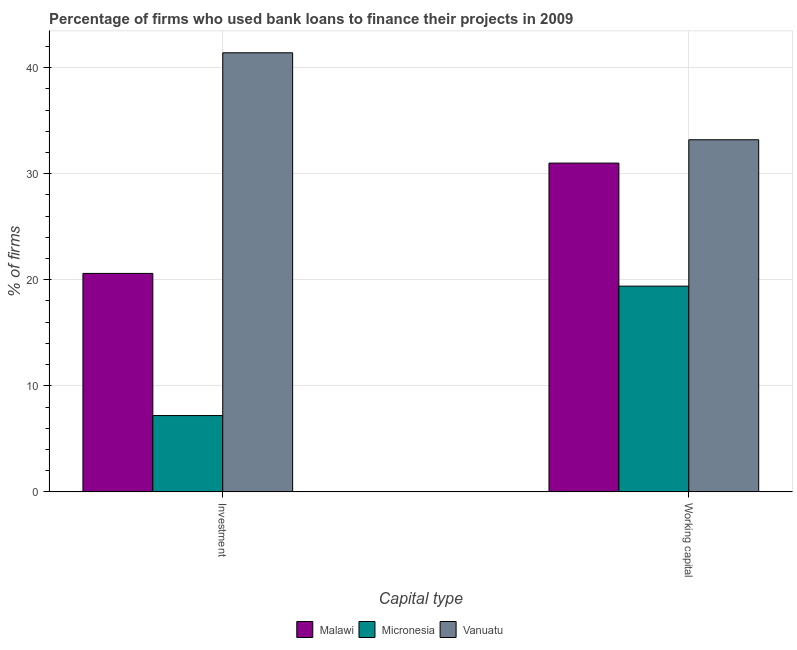How many different coloured bars are there?
Your answer should be very brief. 3. How many bars are there on the 1st tick from the left?
Ensure brevity in your answer.  3. What is the label of the 2nd group of bars from the left?
Provide a short and direct response. Working capital. What is the percentage of firms using banks to finance working capital in Vanuatu?
Make the answer very short. 33.2. Across all countries, what is the maximum percentage of firms using banks to finance working capital?
Your response must be concise. 33.2. Across all countries, what is the minimum percentage of firms using banks to finance investment?
Your response must be concise. 7.2. In which country was the percentage of firms using banks to finance investment maximum?
Offer a very short reply. Vanuatu. In which country was the percentage of firms using banks to finance working capital minimum?
Provide a short and direct response. Micronesia. What is the total percentage of firms using banks to finance working capital in the graph?
Provide a short and direct response. 83.6. What is the difference between the percentage of firms using banks to finance investment in Malawi and that in Vanuatu?
Your response must be concise. -20.8. What is the difference between the percentage of firms using banks to finance investment in Vanuatu and the percentage of firms using banks to finance working capital in Malawi?
Offer a very short reply. 10.4. What is the average percentage of firms using banks to finance working capital per country?
Provide a short and direct response. 27.87. What is the difference between the percentage of firms using banks to finance working capital and percentage of firms using banks to finance investment in Vanuatu?
Your answer should be very brief. -8.2. What is the ratio of the percentage of firms using banks to finance working capital in Micronesia to that in Malawi?
Make the answer very short. 0.63. In how many countries, is the percentage of firms using banks to finance investment greater than the average percentage of firms using banks to finance investment taken over all countries?
Ensure brevity in your answer.  1. What does the 3rd bar from the left in Working capital represents?
Offer a terse response. Vanuatu. What does the 1st bar from the right in Working capital represents?
Make the answer very short. Vanuatu. How many bars are there?
Your answer should be compact. 6. Are all the bars in the graph horizontal?
Your answer should be very brief. No. Are the values on the major ticks of Y-axis written in scientific E-notation?
Make the answer very short. No. How many legend labels are there?
Keep it short and to the point. 3. How are the legend labels stacked?
Give a very brief answer. Horizontal. What is the title of the graph?
Offer a terse response. Percentage of firms who used bank loans to finance their projects in 2009. Does "Croatia" appear as one of the legend labels in the graph?
Offer a very short reply. No. What is the label or title of the X-axis?
Your answer should be compact. Capital type. What is the label or title of the Y-axis?
Your answer should be compact. % of firms. What is the % of firms of Malawi in Investment?
Keep it short and to the point. 20.6. What is the % of firms in Vanuatu in Investment?
Make the answer very short. 41.4. What is the % of firms in Vanuatu in Working capital?
Keep it short and to the point. 33.2. Across all Capital type, what is the maximum % of firms of Vanuatu?
Provide a short and direct response. 41.4. Across all Capital type, what is the minimum % of firms of Malawi?
Make the answer very short. 20.6. Across all Capital type, what is the minimum % of firms in Vanuatu?
Your response must be concise. 33.2. What is the total % of firms of Malawi in the graph?
Keep it short and to the point. 51.6. What is the total % of firms in Micronesia in the graph?
Provide a short and direct response. 26.6. What is the total % of firms in Vanuatu in the graph?
Keep it short and to the point. 74.6. What is the difference between the % of firms of Malawi in Investment and the % of firms of Micronesia in Working capital?
Provide a succinct answer. 1.2. What is the difference between the % of firms of Malawi in Investment and the % of firms of Vanuatu in Working capital?
Your answer should be very brief. -12.6. What is the difference between the % of firms in Micronesia in Investment and the % of firms in Vanuatu in Working capital?
Provide a short and direct response. -26. What is the average % of firms in Malawi per Capital type?
Make the answer very short. 25.8. What is the average % of firms in Vanuatu per Capital type?
Your answer should be very brief. 37.3. What is the difference between the % of firms of Malawi and % of firms of Vanuatu in Investment?
Your answer should be compact. -20.8. What is the difference between the % of firms of Micronesia and % of firms of Vanuatu in Investment?
Your response must be concise. -34.2. What is the difference between the % of firms of Malawi and % of firms of Micronesia in Working capital?
Give a very brief answer. 11.6. What is the difference between the % of firms in Malawi and % of firms in Vanuatu in Working capital?
Your answer should be compact. -2.2. What is the ratio of the % of firms in Malawi in Investment to that in Working capital?
Keep it short and to the point. 0.66. What is the ratio of the % of firms of Micronesia in Investment to that in Working capital?
Offer a terse response. 0.37. What is the ratio of the % of firms in Vanuatu in Investment to that in Working capital?
Keep it short and to the point. 1.25. What is the difference between the highest and the second highest % of firms in Micronesia?
Ensure brevity in your answer.  12.2. What is the difference between the highest and the second highest % of firms in Vanuatu?
Make the answer very short. 8.2. What is the difference between the highest and the lowest % of firms in Micronesia?
Offer a terse response. 12.2. 